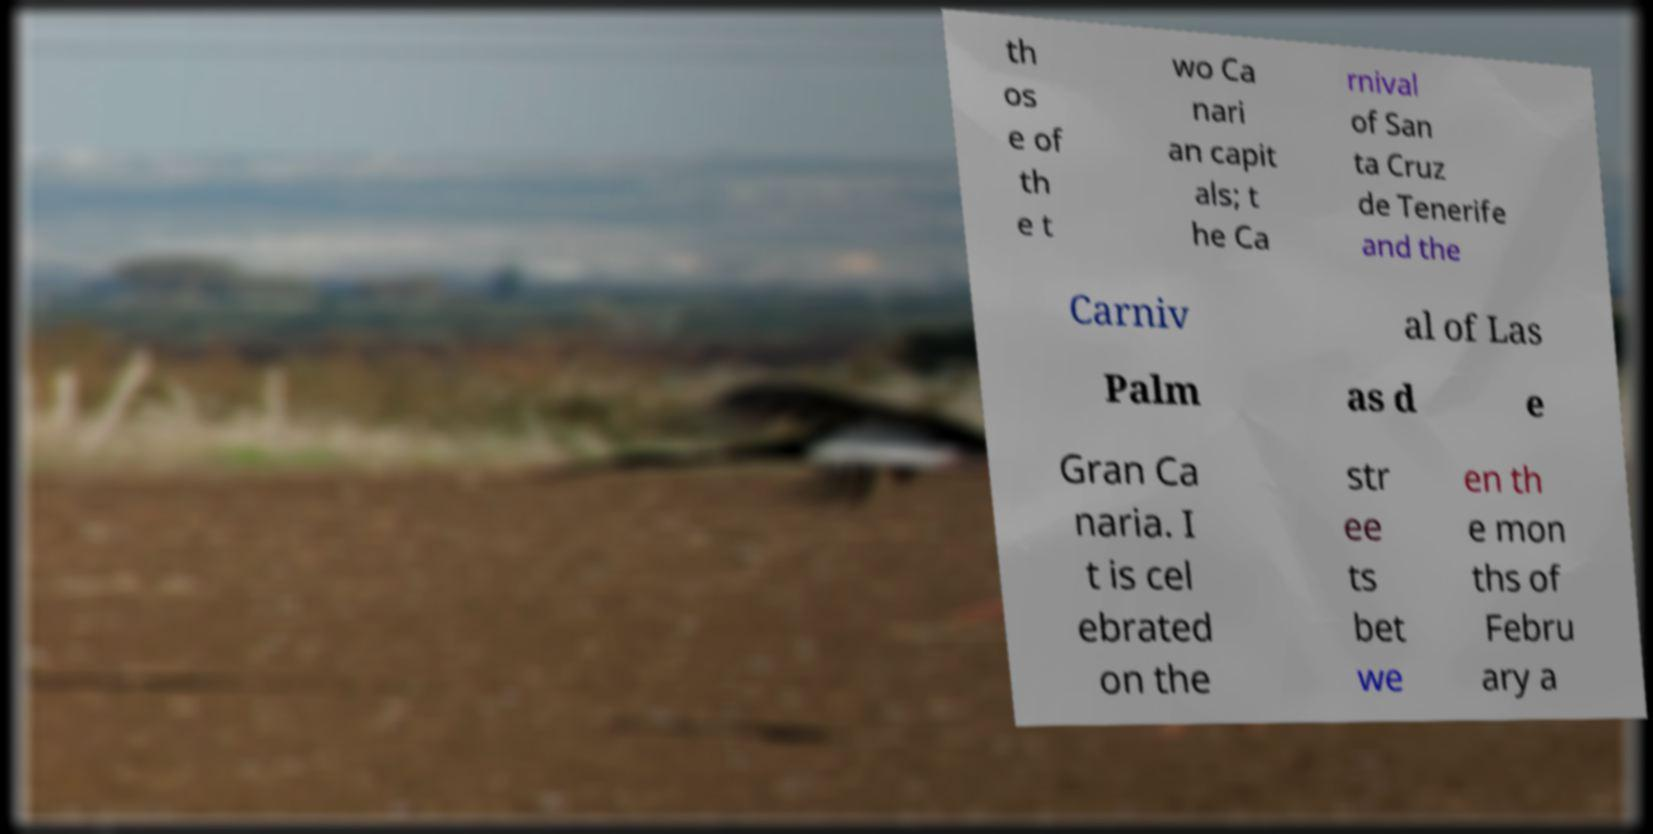For documentation purposes, I need the text within this image transcribed. Could you provide that? th os e of th e t wo Ca nari an capit als; t he Ca rnival of San ta Cruz de Tenerife and the Carniv al of Las Palm as d e Gran Ca naria. I t is cel ebrated on the str ee ts bet we en th e mon ths of Febru ary a 